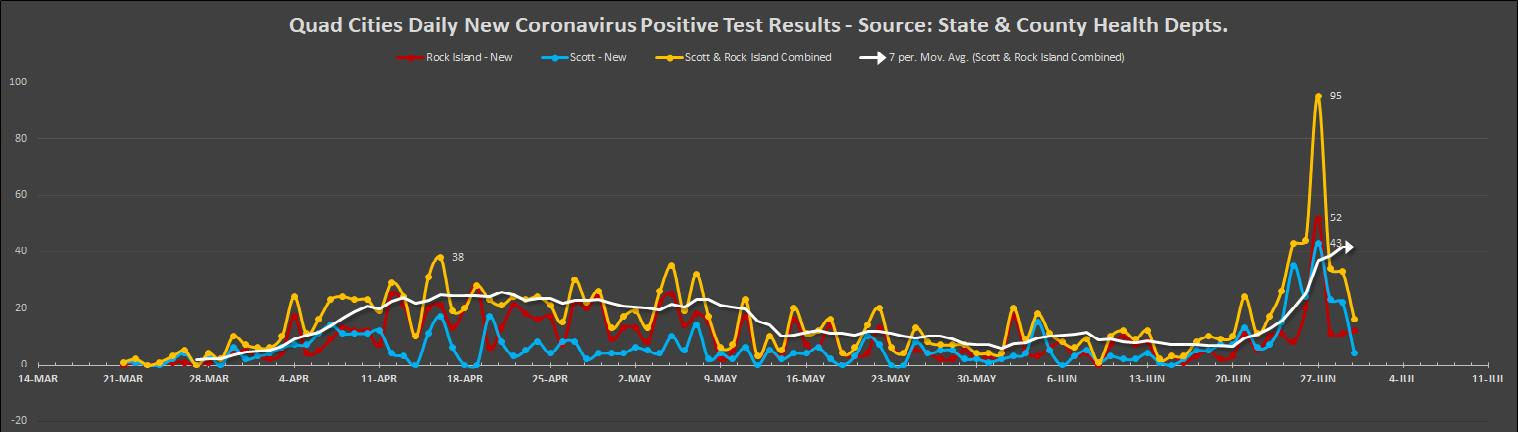Highlight a few significant elements in this photo. The color used to represent Scott -New-blue is blue. Rock Island uses the color red to represent itself. 